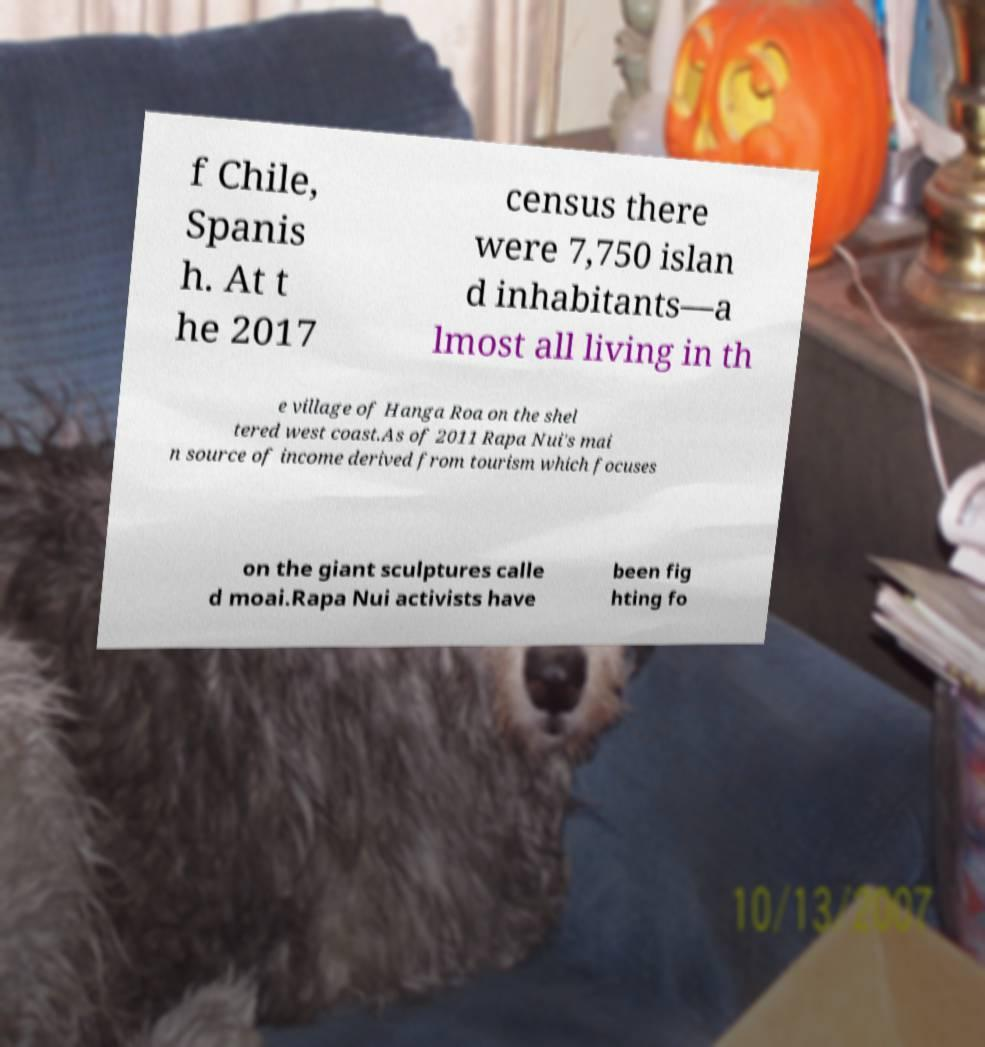Could you assist in decoding the text presented in this image and type it out clearly? f Chile, Spanis h. At t he 2017 census there were 7,750 islan d inhabitants—a lmost all living in th e village of Hanga Roa on the shel tered west coast.As of 2011 Rapa Nui's mai n source of income derived from tourism which focuses on the giant sculptures calle d moai.Rapa Nui activists have been fig hting fo 